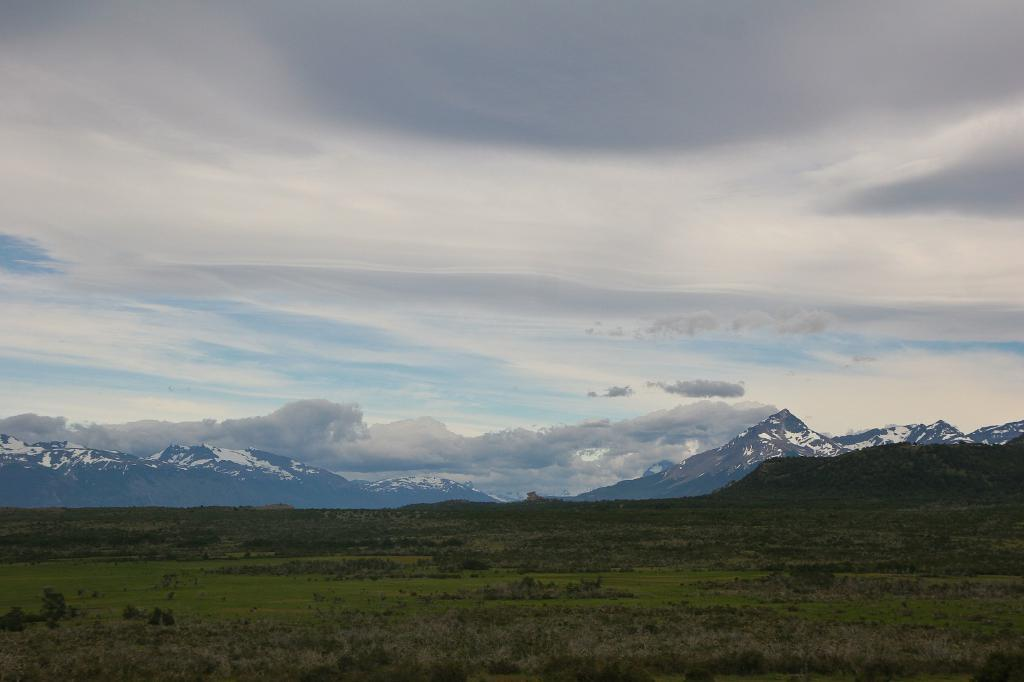What type of terrain is visible at the bottom of the image? There is grass at the bottom of the image. What type of natural features can be seen in the background of the image? There are mountains with snow in the background of the image. What part of the natural environment is visible in the image? The sky is visible in the image. What can be observed in the sky in the image? Clouds are present in the sky. What type of nose can be seen on the mountain in the image? There is no nose present on the mountain in the image; it is a natural geological feature. 